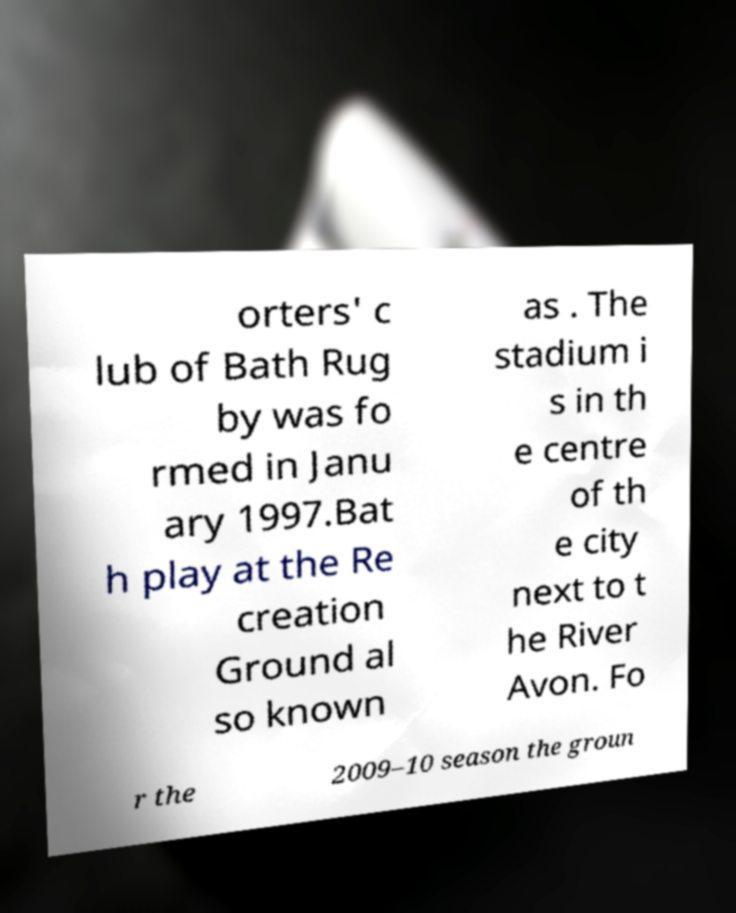Please identify and transcribe the text found in this image. orters' c lub of Bath Rug by was fo rmed in Janu ary 1997.Bat h play at the Re creation Ground al so known as . The stadium i s in th e centre of th e city next to t he River Avon. Fo r the 2009–10 season the groun 